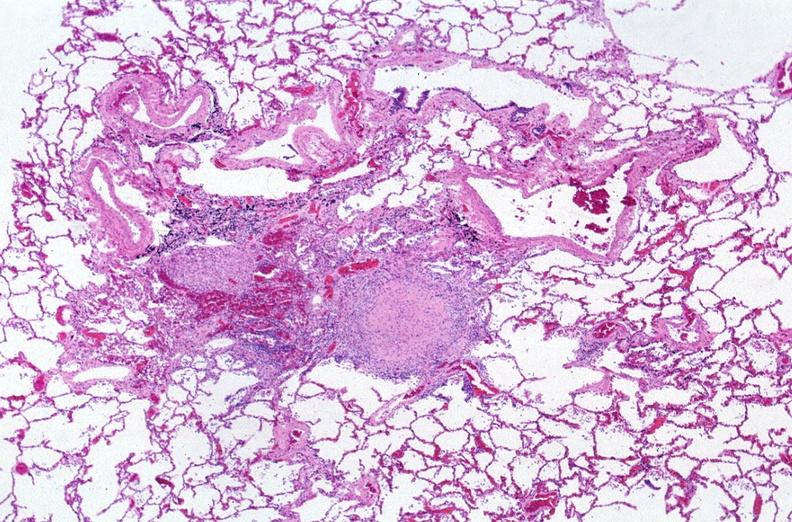what does this image show?
Answer the question using a single word or phrase. Lung 